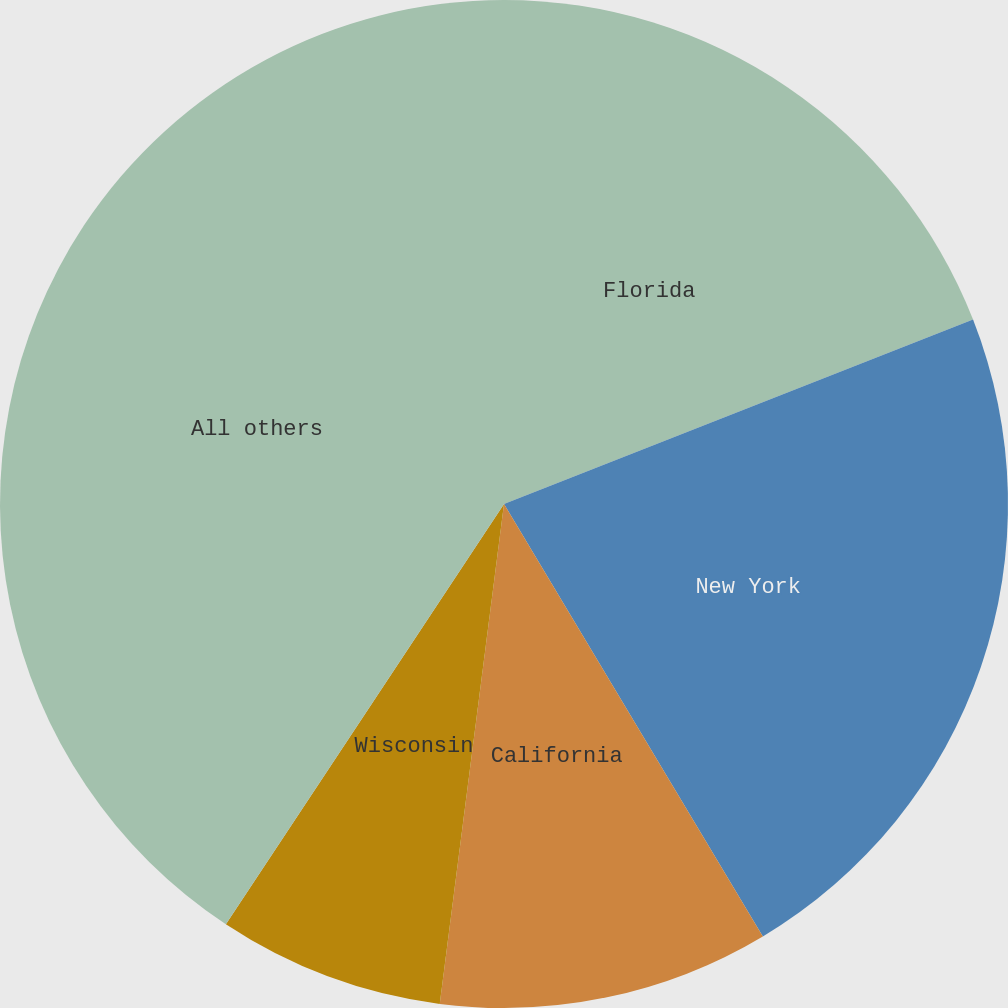Convert chart to OTSL. <chart><loc_0><loc_0><loc_500><loc_500><pie_chart><fcel>Florida<fcel>New York<fcel>California<fcel>Wisconsin<fcel>All others<nl><fcel>19.04%<fcel>22.38%<fcel>10.62%<fcel>7.27%<fcel>40.7%<nl></chart> 